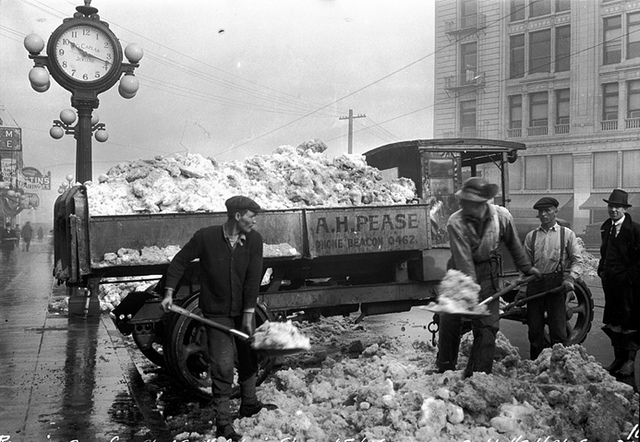<image>What country is this? It is ambiguous to determine the country without any image. What country is this? I am not sure which country this is. It can be either USA, England, Russia, Germany, or China. 